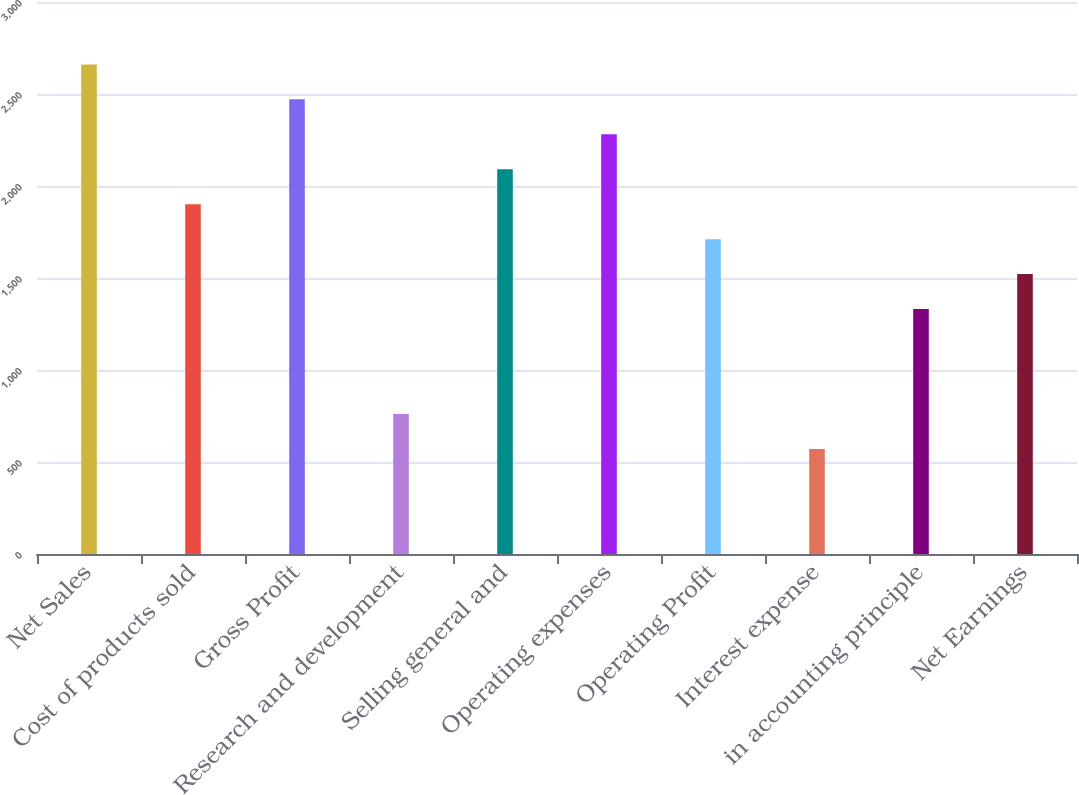Convert chart. <chart><loc_0><loc_0><loc_500><loc_500><bar_chart><fcel>Net Sales<fcel>Cost of products sold<fcel>Gross Profit<fcel>Research and development<fcel>Selling general and<fcel>Operating expenses<fcel>Operating Profit<fcel>Interest expense<fcel>in accounting principle<fcel>Net Earnings<nl><fcel>2660.84<fcel>1901<fcel>2470.88<fcel>761.24<fcel>2090.96<fcel>2280.92<fcel>1711.04<fcel>571.28<fcel>1331.12<fcel>1521.08<nl></chart> 